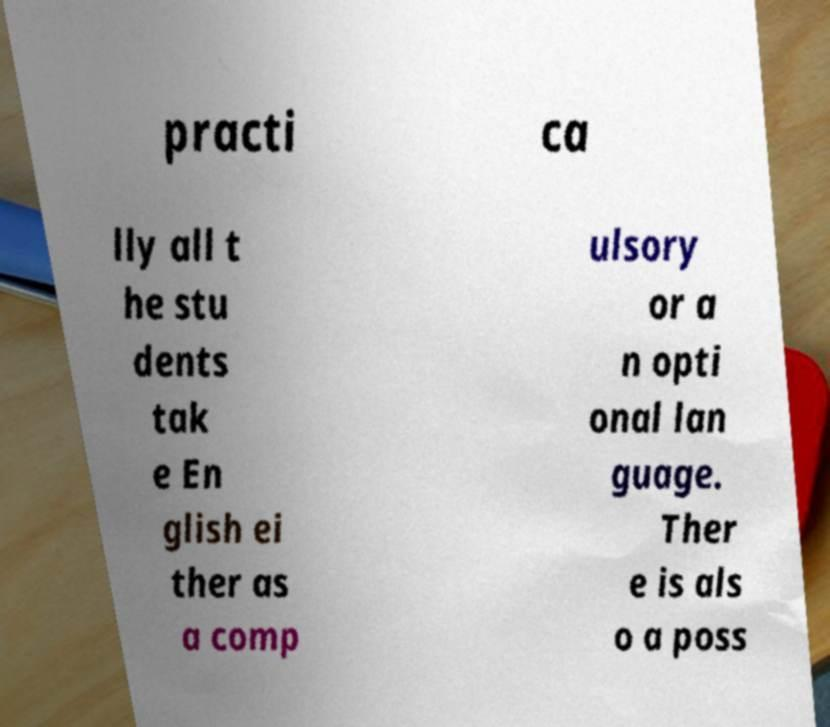Could you extract and type out the text from this image? practi ca lly all t he stu dents tak e En glish ei ther as a comp ulsory or a n opti onal lan guage. Ther e is als o a poss 